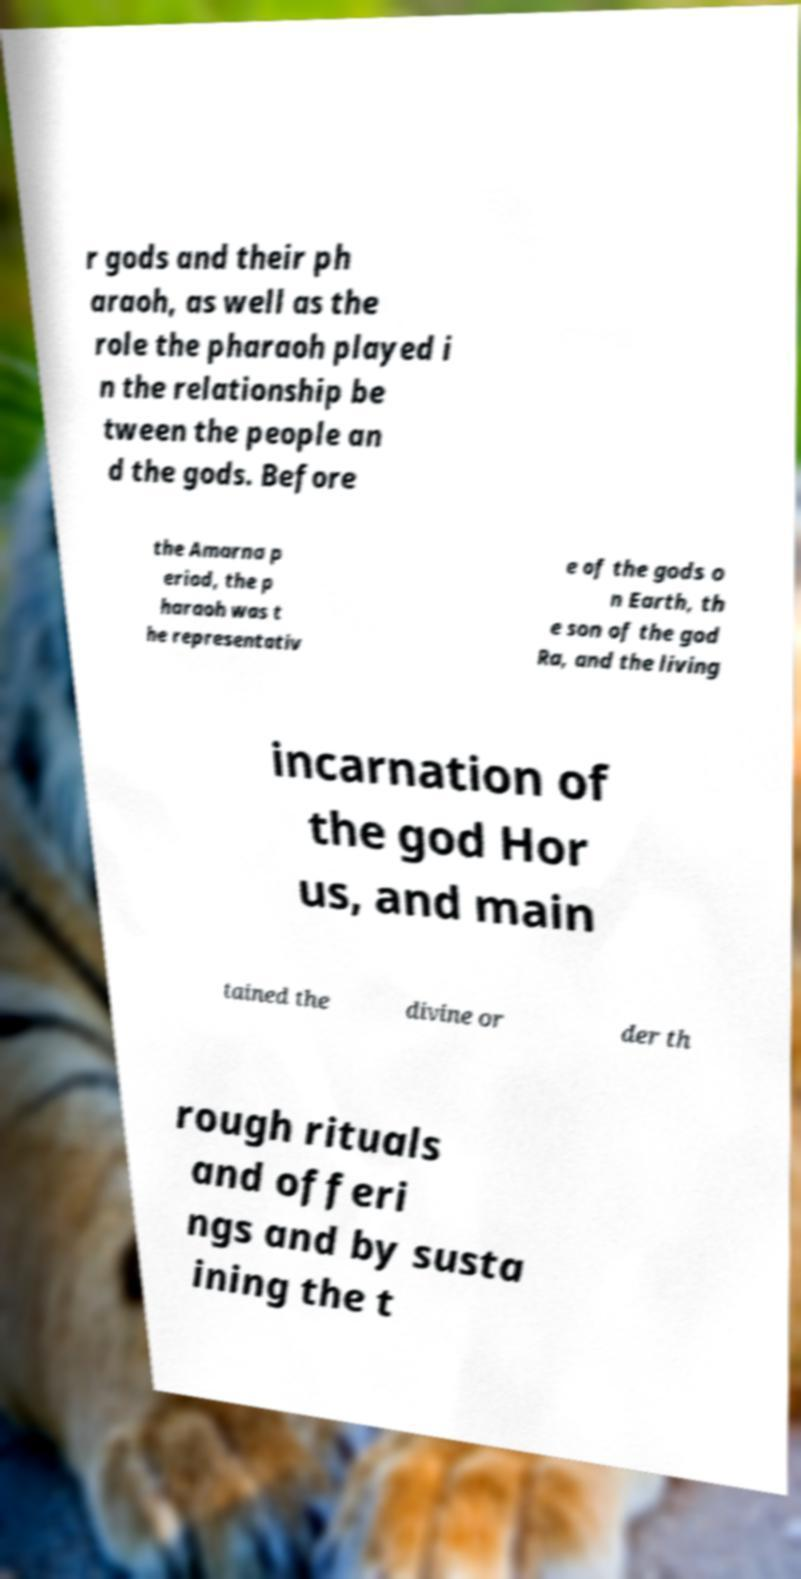Could you assist in decoding the text presented in this image and type it out clearly? r gods and their ph araoh, as well as the role the pharaoh played i n the relationship be tween the people an d the gods. Before the Amarna p eriod, the p haraoh was t he representativ e of the gods o n Earth, th e son of the god Ra, and the living incarnation of the god Hor us, and main tained the divine or der th rough rituals and offeri ngs and by susta ining the t 